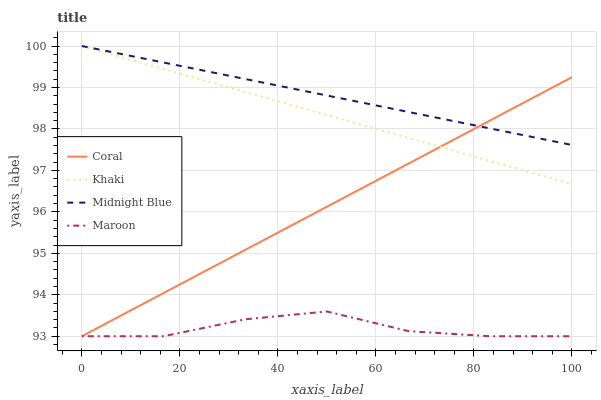Does Maroon have the minimum area under the curve?
Answer yes or no. Yes. Does Midnight Blue have the maximum area under the curve?
Answer yes or no. Yes. Does Khaki have the minimum area under the curve?
Answer yes or no. No. Does Khaki have the maximum area under the curve?
Answer yes or no. No. Is Midnight Blue the smoothest?
Answer yes or no. Yes. Is Maroon the roughest?
Answer yes or no. Yes. Is Khaki the smoothest?
Answer yes or no. No. Is Khaki the roughest?
Answer yes or no. No. Does Coral have the lowest value?
Answer yes or no. Yes. Does Khaki have the lowest value?
Answer yes or no. No. Does Midnight Blue have the highest value?
Answer yes or no. Yes. Does Maroon have the highest value?
Answer yes or no. No. Is Maroon less than Khaki?
Answer yes or no. Yes. Is Midnight Blue greater than Maroon?
Answer yes or no. Yes. Does Midnight Blue intersect Coral?
Answer yes or no. Yes. Is Midnight Blue less than Coral?
Answer yes or no. No. Is Midnight Blue greater than Coral?
Answer yes or no. No. Does Maroon intersect Khaki?
Answer yes or no. No. 